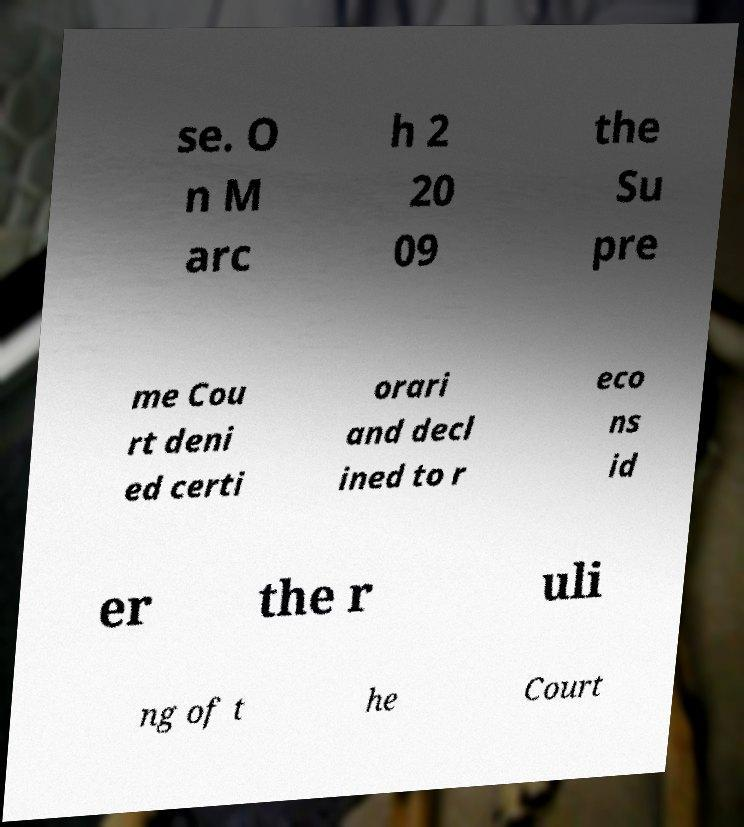Please identify and transcribe the text found in this image. se. O n M arc h 2 20 09 the Su pre me Cou rt deni ed certi orari and decl ined to r eco ns id er the r uli ng of t he Court 